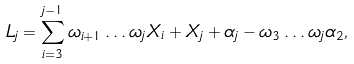<formula> <loc_0><loc_0><loc_500><loc_500>L _ { j } & = \sum _ { i = 3 } ^ { j - 1 } \omega _ { i + 1 } \dots \omega _ { j } X _ { i } + X _ { j } + \alpha _ { j } - \omega _ { 3 } \dots \omega _ { j } \alpha _ { 2 } ,</formula> 